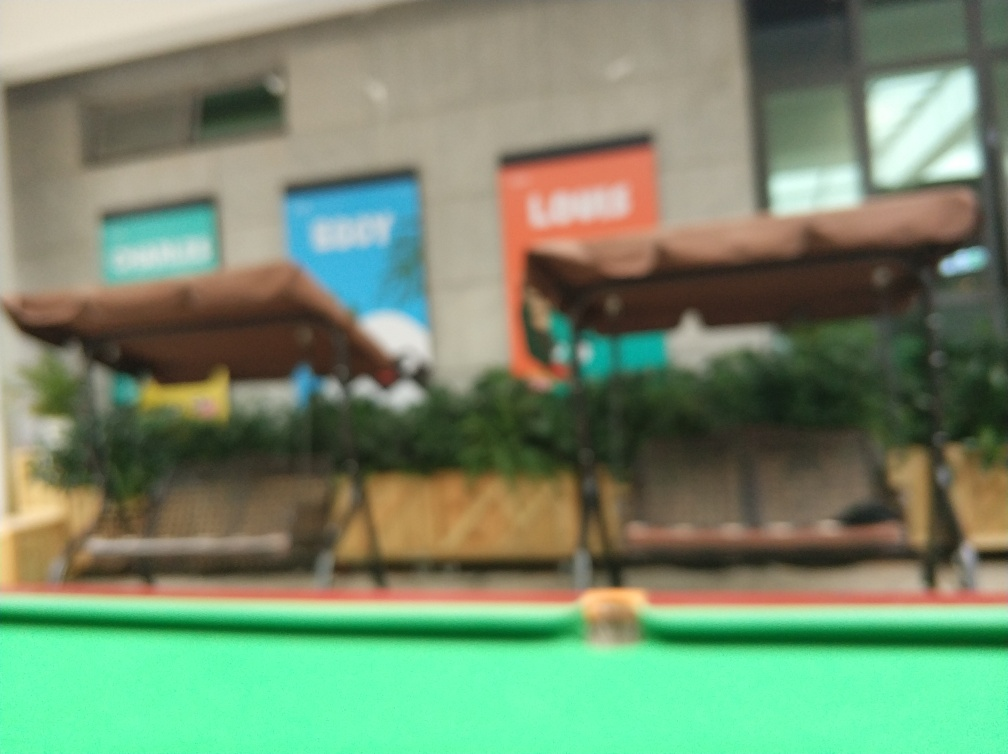Does the overall image appear blurry?
 Yes 